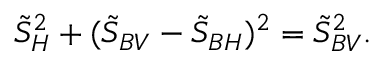<formula> <loc_0><loc_0><loc_500><loc_500>\tilde { S } _ { H } ^ { 2 } + ( \tilde { S } _ { B V } - \tilde { S } _ { B H } ) ^ { 2 } = \tilde { S } _ { B V } ^ { 2 } .</formula> 